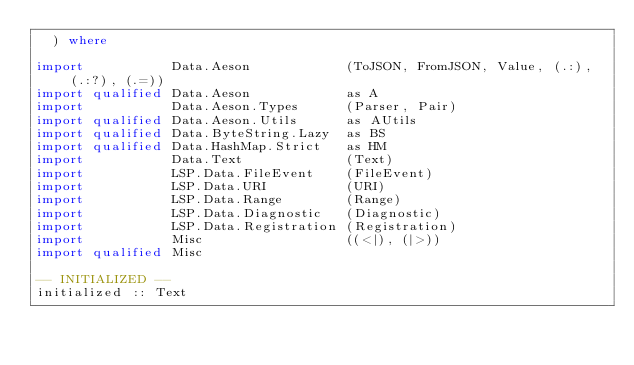Convert code to text. <code><loc_0><loc_0><loc_500><loc_500><_Haskell_>  ) where

import           Data.Aeson            (ToJSON, FromJSON, Value, (.:), (.:?), (.=))
import qualified Data.Aeson            as A
import           Data.Aeson.Types      (Parser, Pair)
import qualified Data.Aeson.Utils      as AUtils
import qualified Data.ByteString.Lazy  as BS
import qualified Data.HashMap.Strict   as HM
import           Data.Text             (Text)
import           LSP.Data.FileEvent    (FileEvent)
import           LSP.Data.URI          (URI)
import           LSP.Data.Range        (Range)
import           LSP.Data.Diagnostic   (Diagnostic)
import           LSP.Data.Registration (Registration)
import           Misc                  ((<|), (|>))
import qualified Misc

-- INITIALIZED --
initialized :: Text</code> 